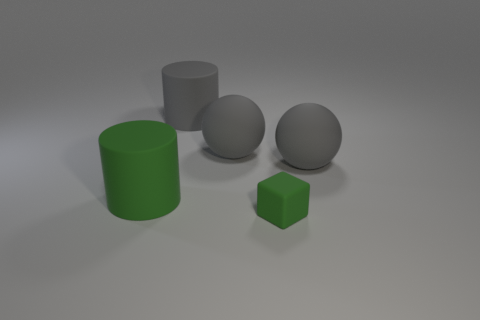Add 1 large yellow rubber balls. How many objects exist? 6 Subtract 1 cylinders. How many cylinders are left? 1 Subtract all gray cylinders. How many cylinders are left? 1 Subtract 0 cyan spheres. How many objects are left? 5 Subtract all balls. How many objects are left? 3 Subtract all purple cylinders. Subtract all gray balls. How many cylinders are left? 2 Subtract all tiny matte blocks. Subtract all big gray things. How many objects are left? 1 Add 4 cubes. How many cubes are left? 5 Add 3 big objects. How many big objects exist? 7 